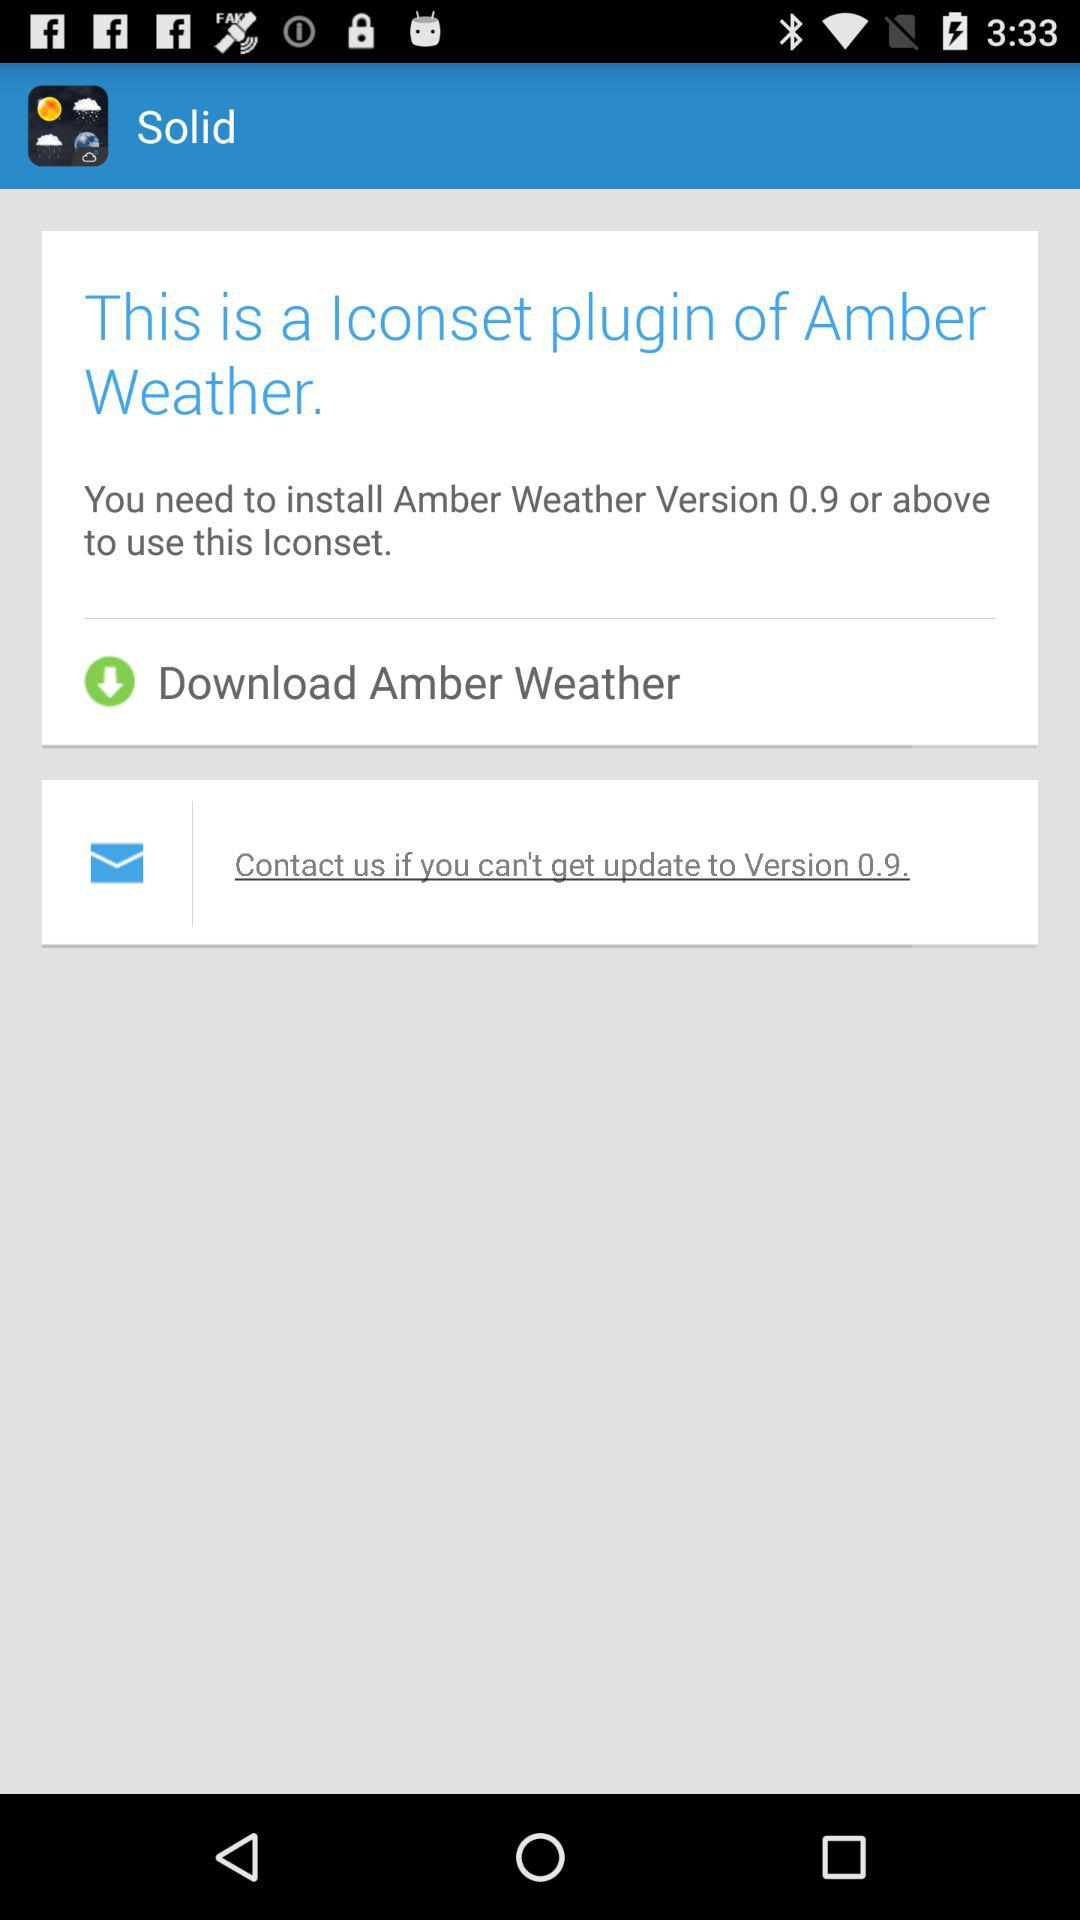What weather application is to be downloaded? The application is " Amber Weather". 